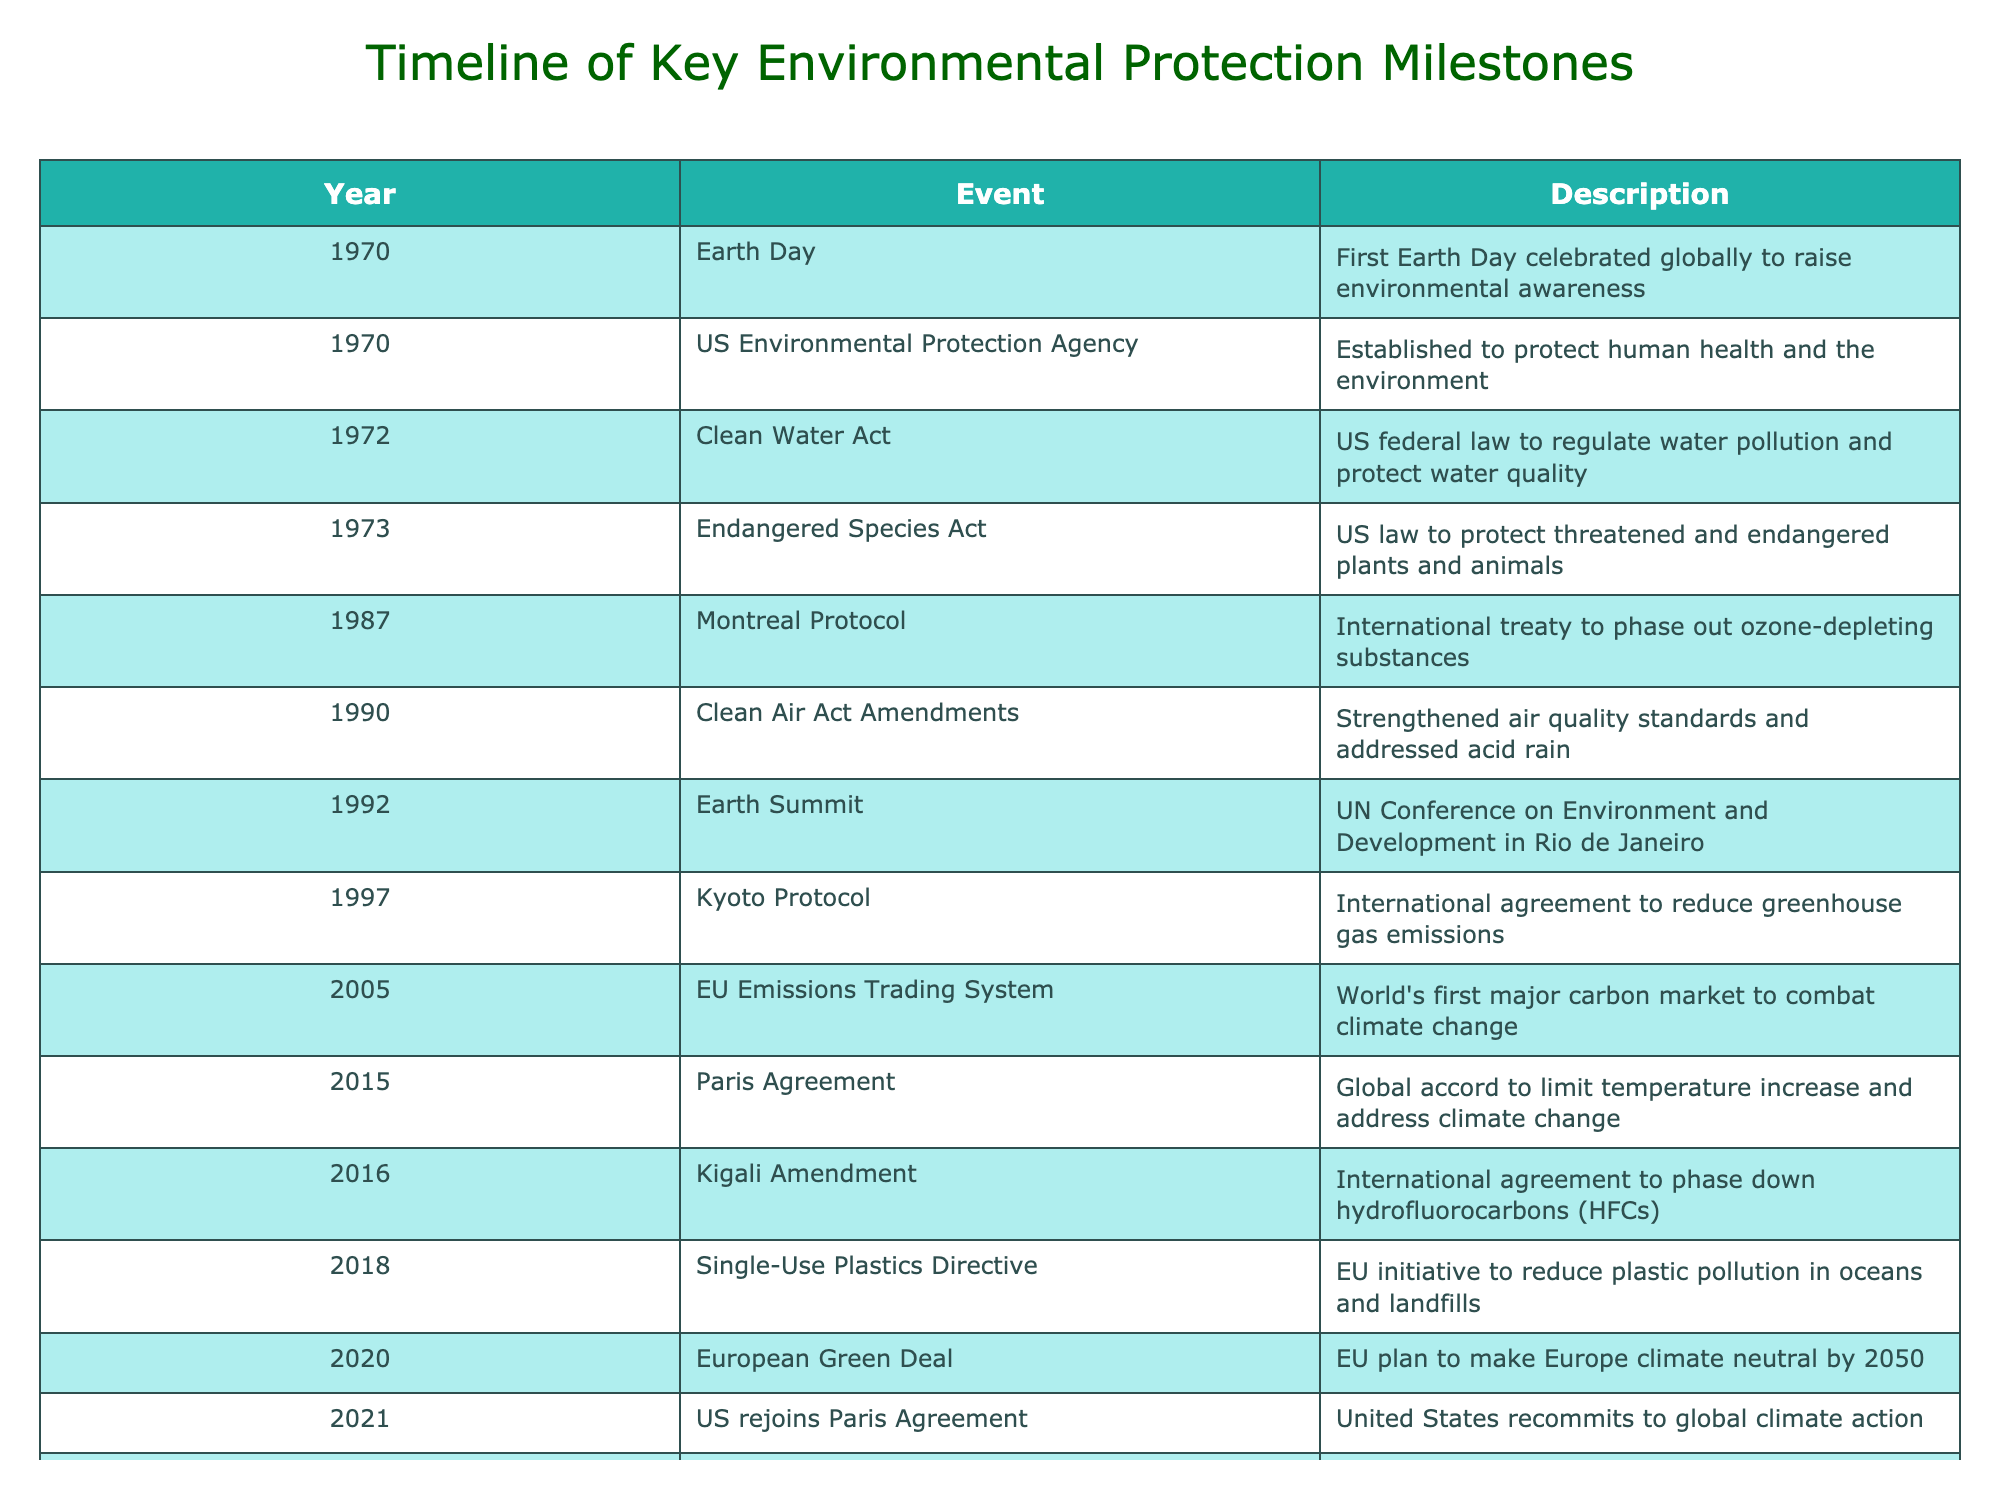What year was Earth Day first celebrated? Referring to the table, the row corresponding to Earth Day lists the year as 1970.
Answer: 1970 Which Act was established to protect threatened and endangered species? The Endangered Species Act is mentioned in the row for the year 1973, stating its purpose to protect threatened and endangered plants and animals.
Answer: Endangered Species Act What is the difference in years between the Clean Water Act and the Clean Air Act Amendments? The Clean Water Act was enacted in 1972, and the Clean Air Act Amendments occurred in 1990. The difference in years is 1990 - 1972 = 18 years.
Answer: 18 years True or False: The EU Emissions Trading System was established before the Kyoto Protocol. The table lists the EU Emissions Trading System in 2005 and the Kyoto Protocol in 1997. Since 2005 is after 1997, the statement is false.
Answer: False What was the significant outcome of the 2015 Paris Agreement? The table indicates that the Paris Agreement aims to limit temperature increase and address climate change, representing a global accord with this purpose.
Answer: Limit temperature increase What do the events of 1987 and 2016 have in common? Both events, the Montreal Protocol (1987) and the Kigali Amendment (2016), involve international agreements related to environmental protection, specifically focusing on substances that harm the ozone layer and climate change respectively.
Answer: International agreements How many environmental events mentioned were established in the 21st century? The table lists the events from the 21st century as follows: EU Emissions Trading System (2005), Paris Agreement (2015), Kigali Amendment (2016), European Green Deal (2020), US rejoins Paris Agreement (2021), and Global Plastics Treaty (2022). Counting these gives a total of 6 events created in the 21st century.
Answer: 6 events Which two milestones occurred in the year 2020? The table indicates the European Green Deal as a key milestone in 2020. No other event for this year is mentioned, so the only milestone is the European Green Deal.
Answer: European Green Deal Determine the time span between the Earth Day celebration and the establishment of the US Environmental Protection Agency. Earth Day was celebrated in 1970, and the US Environmental Protection Agency was established in the same year, 1970. The time span between them is 0 years since both events happened in the same year.
Answer: 0 years 